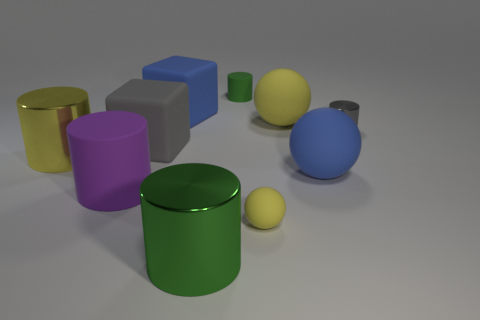There is a gray rubber block; is its size the same as the metallic thing that is behind the gray matte cube?
Your answer should be compact. No. There is a large yellow matte ball to the right of the cylinder behind the blue rubber block; what number of green metal objects are on the right side of it?
Ensure brevity in your answer.  0. What is the size of the cube that is the same color as the tiny metal object?
Keep it short and to the point. Large. Are there any metal cylinders behind the large yellow metallic cylinder?
Your answer should be very brief. Yes. What is the shape of the large green shiny object?
Provide a succinct answer. Cylinder. There is a big purple object that is in front of the blue matte object on the right side of the big shiny cylinder to the right of the blue block; what shape is it?
Your answer should be compact. Cylinder. How many other things are there of the same shape as the small green rubber thing?
Keep it short and to the point. 4. What material is the green thing that is on the left side of the green object behind the big yellow shiny cylinder?
Provide a short and direct response. Metal. Is the big gray block made of the same material as the yellow ball that is in front of the large yellow metal thing?
Give a very brief answer. Yes. There is a yellow thing that is behind the big purple rubber thing and to the right of the big rubber cylinder; what material is it made of?
Keep it short and to the point. Rubber. 